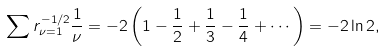Convert formula to latex. <formula><loc_0><loc_0><loc_500><loc_500>\sum r _ { \nu = 1 } ^ { - 1 / 2 } \frac { 1 } { \nu } = - 2 \left ( 1 - \frac { 1 } { 2 } + \frac { 1 } { 3 } - \frac { 1 } { 4 } + \cdots \right ) = - 2 \ln 2 ,</formula> 